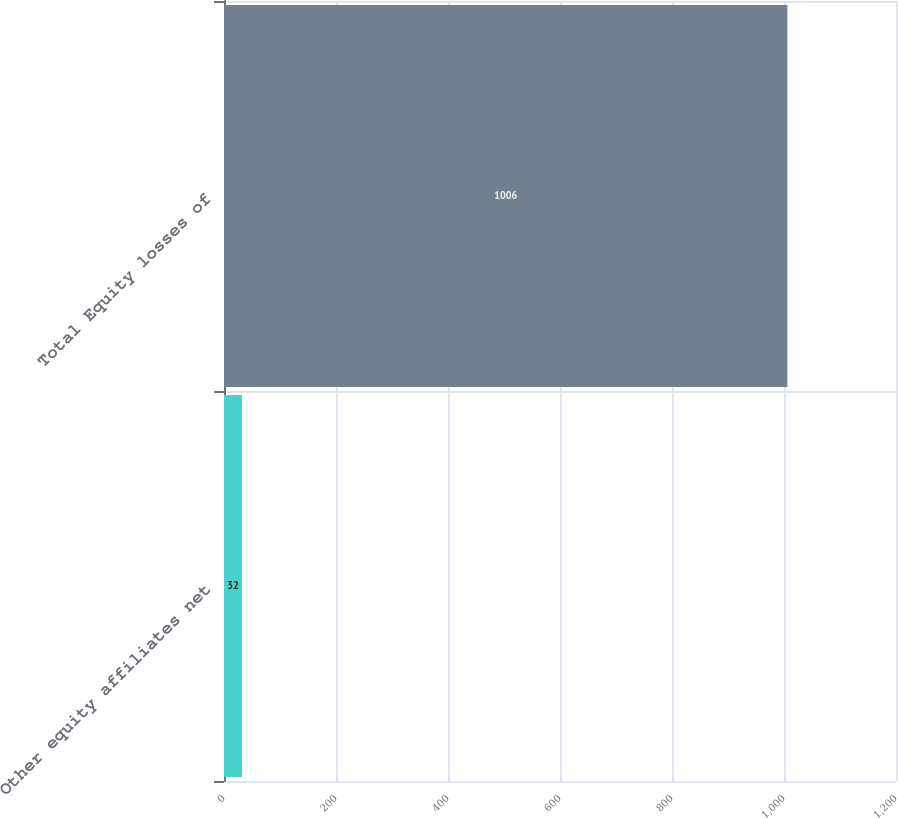Convert chart. <chart><loc_0><loc_0><loc_500><loc_500><bar_chart><fcel>Other equity affiliates net<fcel>Total Equity losses of<nl><fcel>32<fcel>1006<nl></chart> 